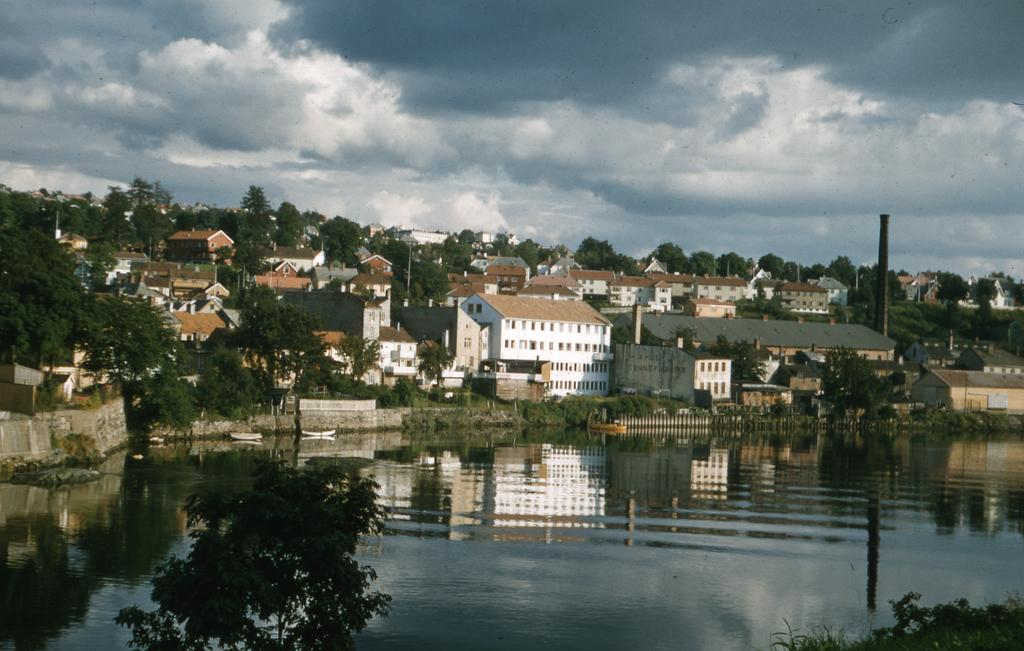What type of structures can be seen in the image? There are many buildings in the image. What other natural elements are present in the image? There are trees and water visible in the image. What is visible in the sky at the top of the image? There are clouds in the sky at the top of the image. Can you describe a specific feature on one of the buildings? There is a chimney on the right side of the image. What type of protest is taking place in the image? There is no protest present in the image; it features buildings, trees, water, clouds, and a chimney. How many potatoes can be seen in the image? There are no potatoes present in the image. 